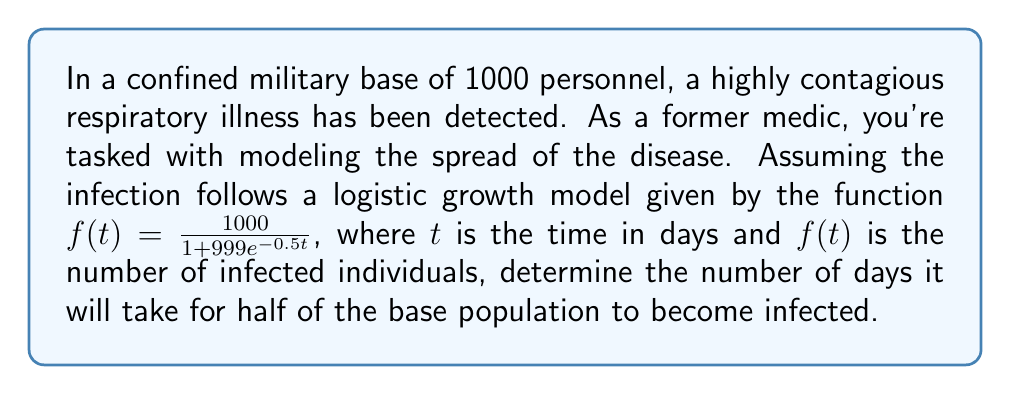What is the answer to this math problem? To solve this problem, we need to follow these steps:

1) We're looking for the time $t$ when half of the population is infected. This means we need to find $t$ when $f(t) = 500$.

2) Set up the equation:

   $500 = \frac{1000}{1 + 999e^{-0.5t}}$

3) Multiply both sides by the denominator:

   $500(1 + 999e^{-0.5t}) = 1000$

4) Expand the left side:

   $500 + 499500e^{-0.5t} = 1000$

5) Subtract 500 from both sides:

   $499500e^{-0.5t} = 500$

6) Divide both sides by 499500:

   $e^{-0.5t} = \frac{1}{999}$

7) Take the natural log of both sides:

   $-0.5t = \ln(\frac{1}{999})$

8) Divide both sides by -0.5:

   $t = -\frac{2}{1}\ln(\frac{1}{999})$

9) Simplify:

   $t = 2\ln(999) \approx 13.81$ days

Therefore, it will take approximately 13.81 days for half of the base population to become infected.
Answer: $2\ln(999) \approx 13.81$ days 